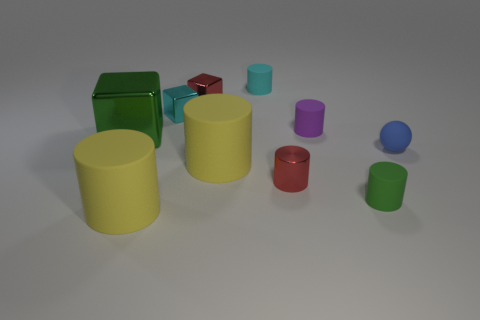Subtract all red cylinders. How many cylinders are left? 5 Subtract all small green cylinders. How many cylinders are left? 5 Subtract all gray cylinders. Subtract all yellow cubes. How many cylinders are left? 6 Subtract all cylinders. How many objects are left? 4 Add 1 tiny cyan cylinders. How many tiny cyan cylinders exist? 2 Subtract 0 purple spheres. How many objects are left? 10 Subtract all tiny metallic things. Subtract all big rubber things. How many objects are left? 5 Add 2 tiny red metal cylinders. How many tiny red metal cylinders are left? 3 